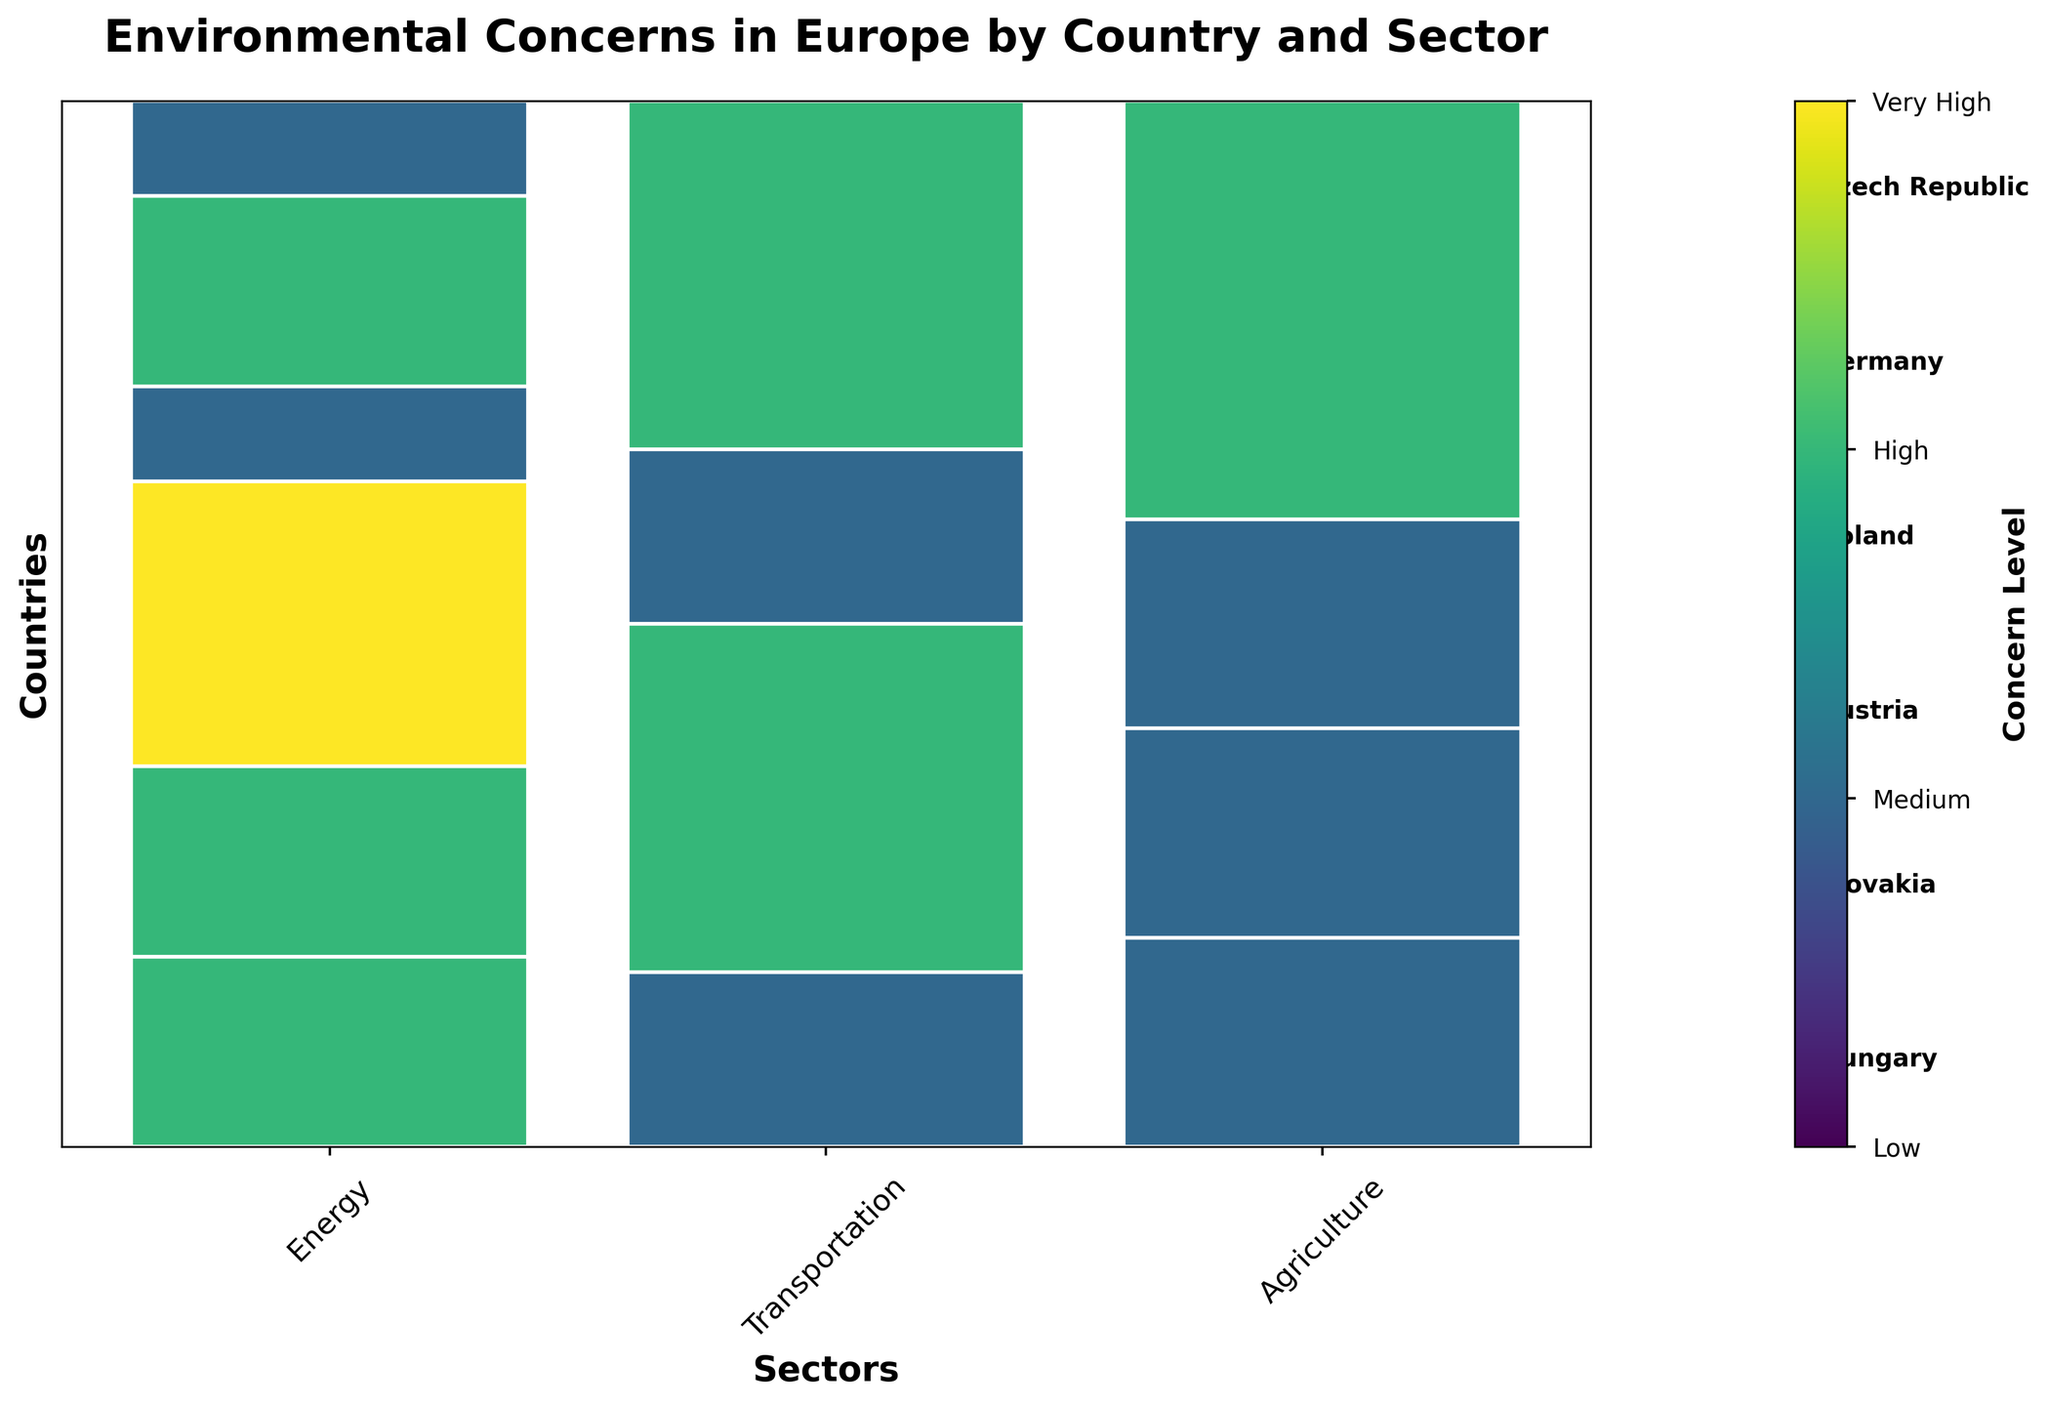What's the title of the mosaic plot? The title can be found at the very top of the figure, it reads: "Environmental Concerns in Europe by Country and Sector."
Answer: Environmental Concerns in Europe by Country and Sector Which country has the highest concern level in the energy sector? By looking at the energy sector bars, the color for the highest concern level (Very High) is present in Poland.
Answer: Poland Which sector in Germany shows the highest level of environmental concern? For Germany, the color indicating the highest concern is found in the transportation sector, which is high.
Answer: Transportation Comparing agriculture across all countries, which country has the highest concern level? The color indicating high concern in agriculture is found in Hungary.
Answer: Hungary Are there any sectors in Austria with very high concern levels? By looking at the sectors for Austria, none of them show the color for very high concern.
Answer: No Which sector in the Czech Republic has the lowest level of concern? In the Czech Republic, the agriculture sector has the color indicating low concern.
Answer: Agriculture Is there any country where the concern level in transportation is low? The country with a low concern level in transportation is Slovakia, as indicated by the respective color.
Answer: Slovakia Which country has medium concern in the most sectors? By counting medium concern level colors, Austria has medium concern in both energy and agriculture sectors, making two in total.
Answer: Austria What's the overall concern trend in Slovakia across all sectors compared to Hungary? Slovakia shows a high concern in energy, low in transportation, and medium in agriculture, while Hungary shows medium in energy, low in transportation, but high in agriculture. Slovakia's overall concern is slightly lower.
Answer: Slovakia has a slightly lower overall concern level compared to Hungary How many countries show high concern in energy? The countries with high concern in energy are Czech Republic, Germany, and Slovakia, making three in total.
Answer: Three 